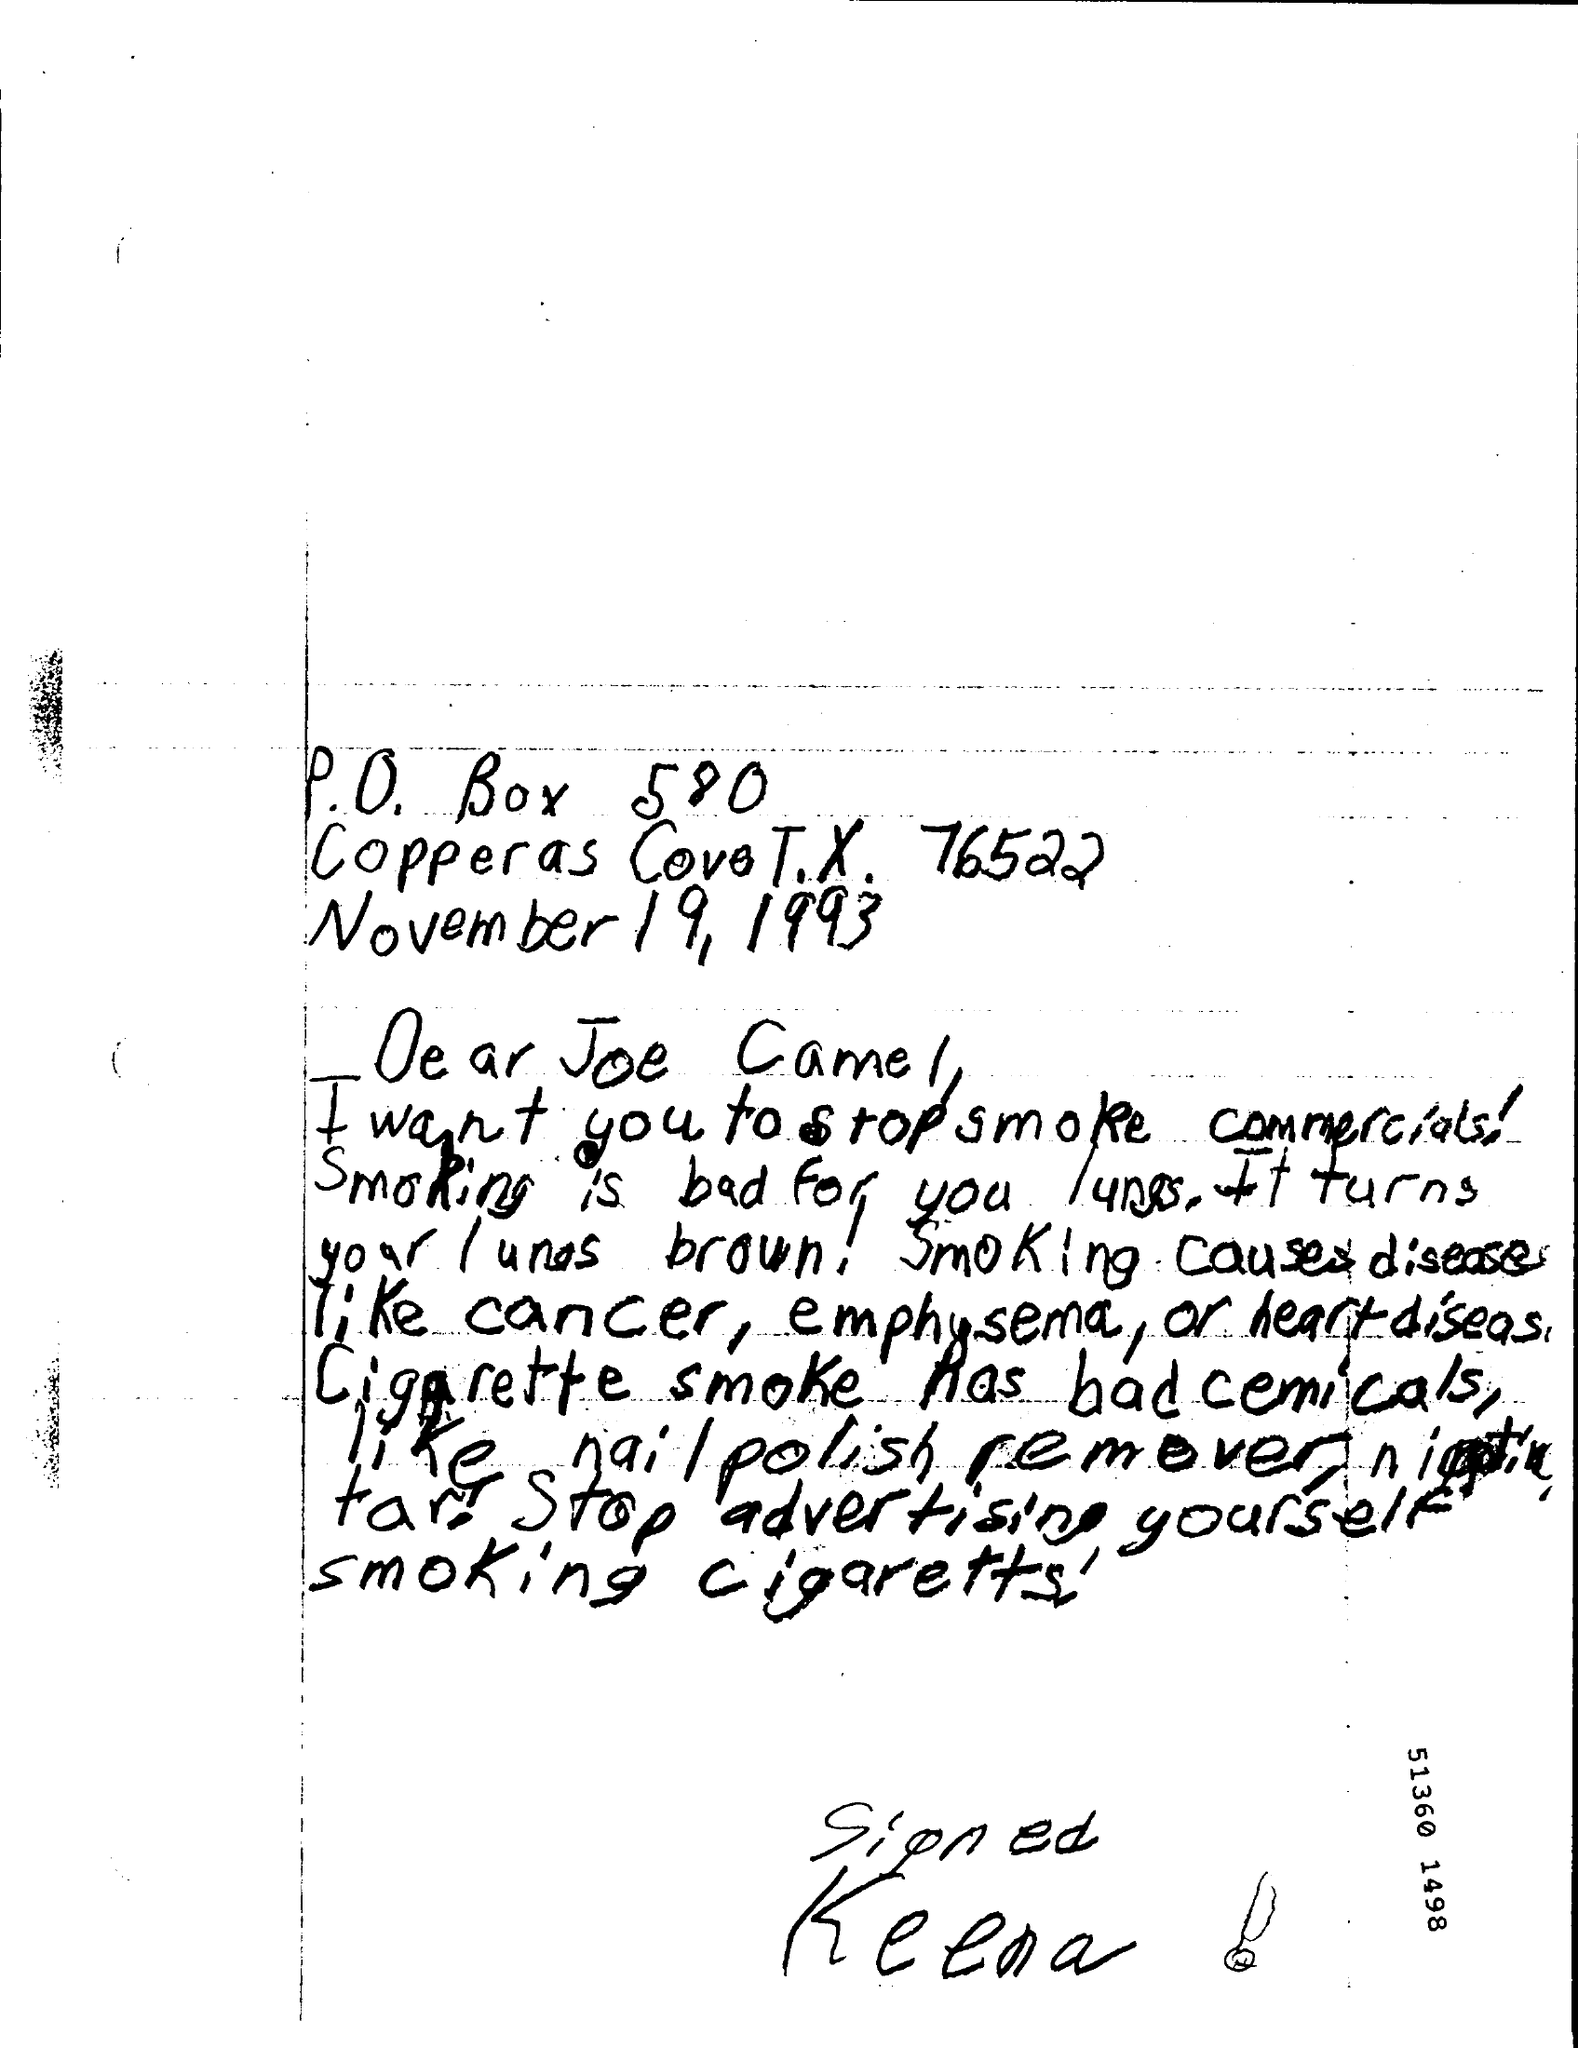What is the Date?
Your response must be concise. November 19, 1993. To Whom is this letter addressed to?
Your response must be concise. Joe Camel. 